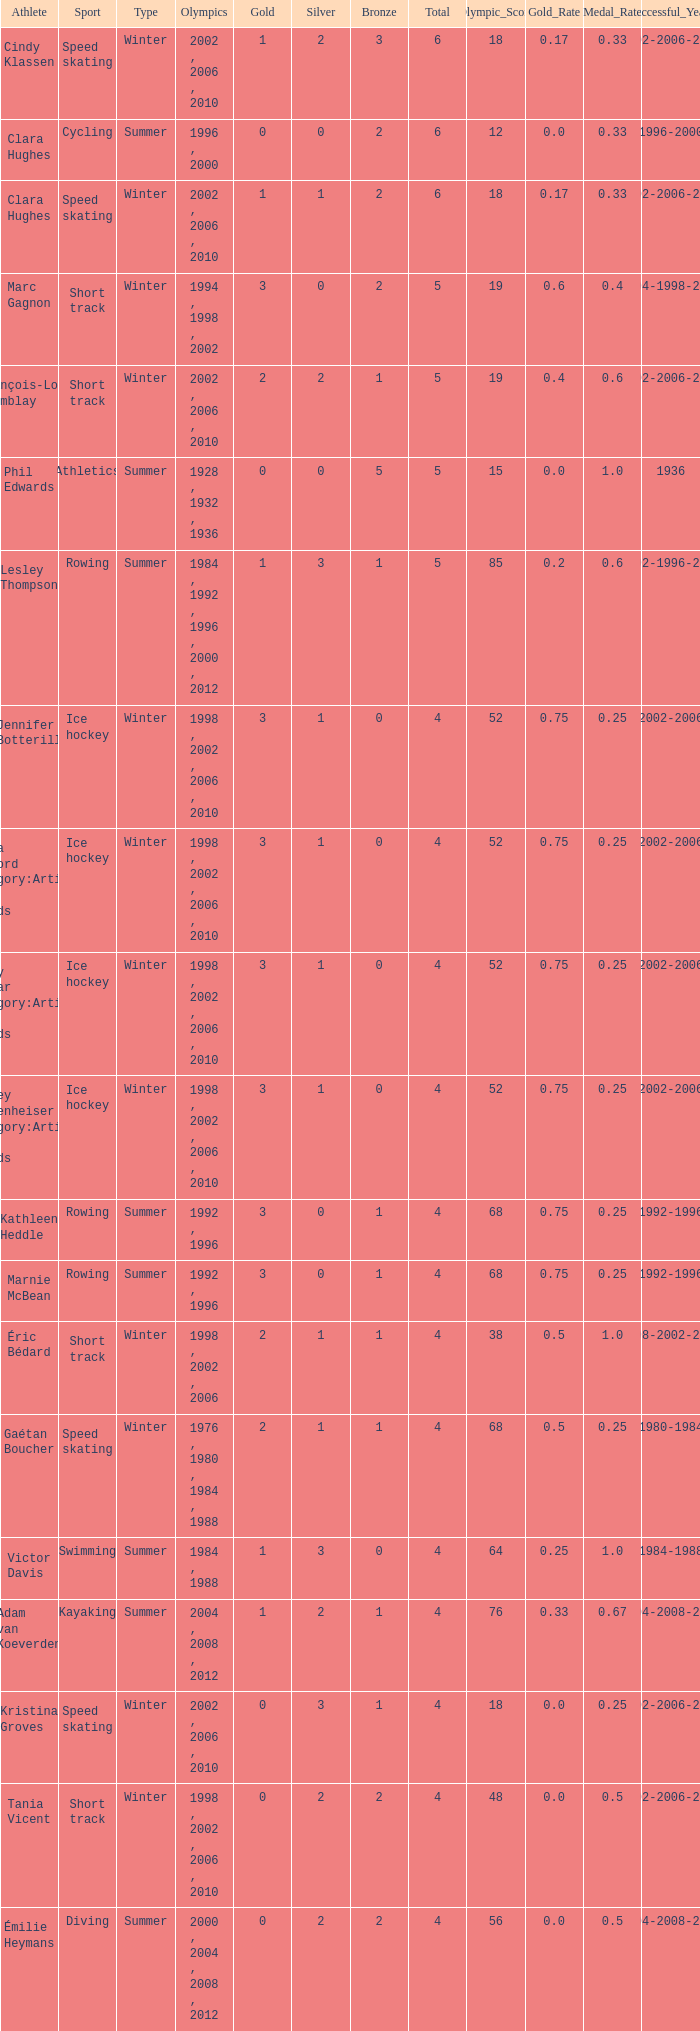What is the highest total medals winter athlete Clara Hughes has? 6.0. 